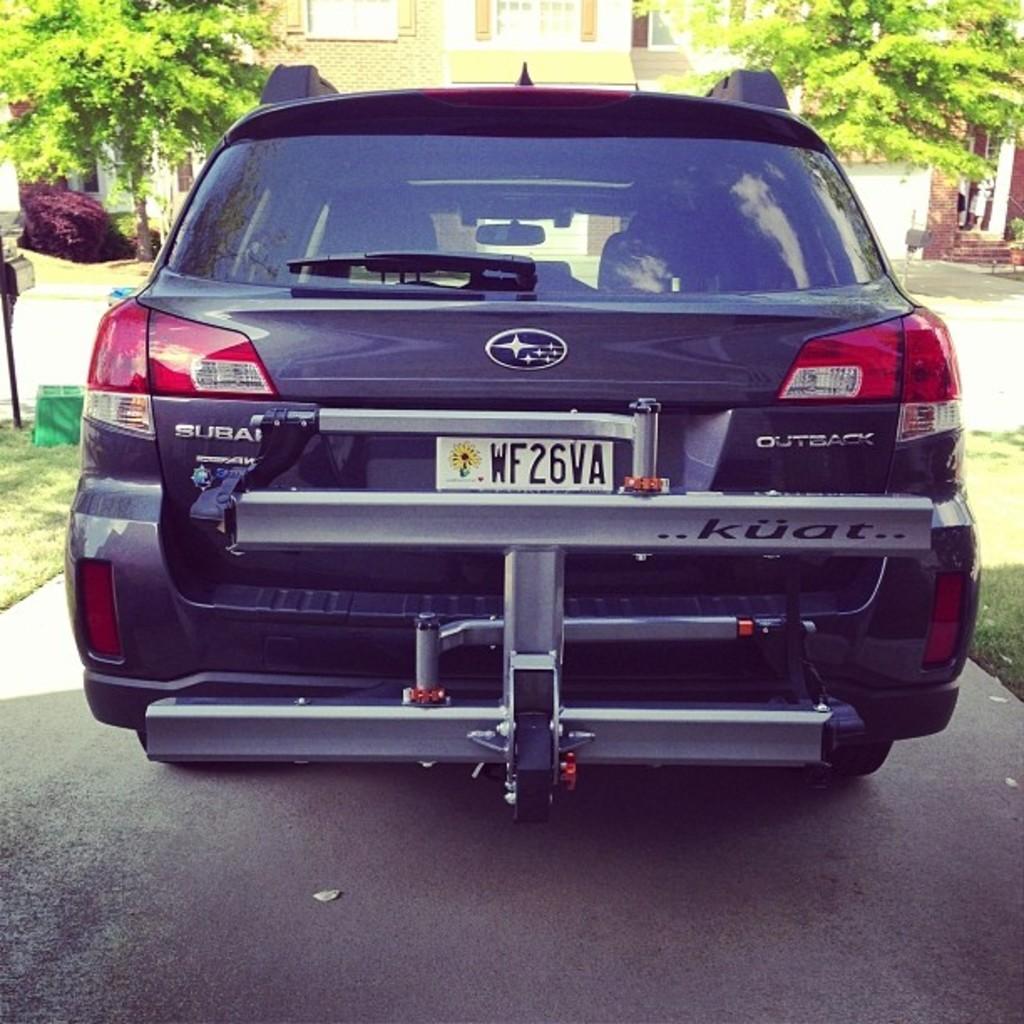What is the plate number?
Provide a short and direct response. Wf26va. 